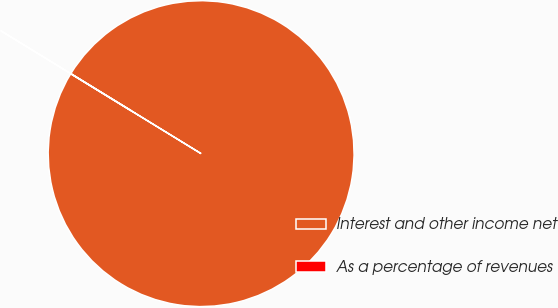Convert chart to OTSL. <chart><loc_0><loc_0><loc_500><loc_500><pie_chart><fcel>Interest and other income net<fcel>As a percentage of revenues<nl><fcel>99.99%<fcel>0.01%<nl></chart> 